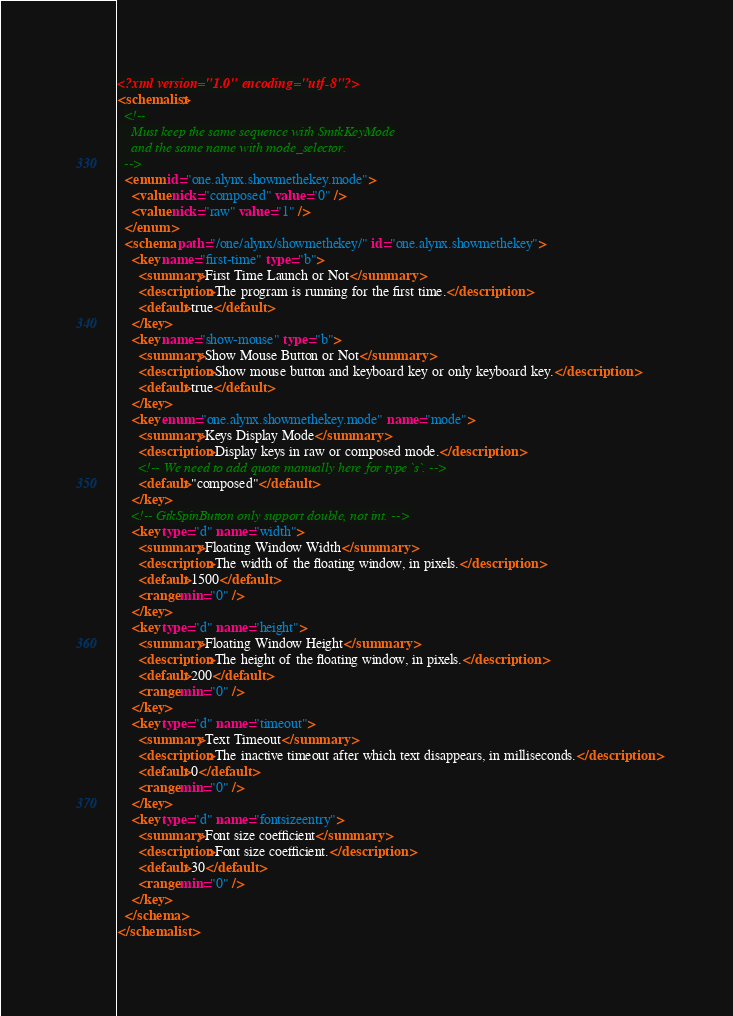<code> <loc_0><loc_0><loc_500><loc_500><_XML_><?xml version="1.0" encoding="utf-8"?>
<schemalist>
  <!--
    Must keep the same sequence with SmtkKeyMode
    and the same name with mode_selector.
  -->
  <enum id="one.alynx.showmethekey.mode">
    <value nick="composed" value="0" />
    <value nick="raw" value="1" />
  </enum>
  <schema path="/one/alynx/showmethekey/" id="one.alynx.showmethekey">
    <key name="first-time" type="b">
      <summary>First Time Launch or Not</summary>
      <description>The program is running for the first time.</description>
      <default>true</default>
    </key>
    <key name="show-mouse" type="b">
      <summary>Show Mouse Button or Not</summary>
      <description>Show mouse button and keyboard key or only keyboard key.</description>
      <default>true</default>
    </key>
    <key enum="one.alynx.showmethekey.mode" name="mode">
      <summary>Keys Display Mode</summary>
      <description>Display keys in raw or composed mode.</description>
      <!-- We need to add quote manually here for type `s`. -->
      <default>"composed"</default>
    </key>
    <!-- GtkSpinButton only support double, not int. -->
    <key type="d" name="width">
      <summary>Floating Window Width</summary>
      <description>The width of the floating window, in pixels.</description>
      <default>1500</default>
      <range min="0" />
    </key>
    <key type="d" name="height">
      <summary>Floating Window Height</summary>
      <description>The height of the floating window, in pixels.</description>
      <default>200</default>
      <range min="0" />
    </key>
    <key type="d" name="timeout">
      <summary>Text Timeout</summary>
      <description>The inactive timeout after which text disappears, in milliseconds.</description>
      <default>0</default>
      <range min="0" />
    </key>
    <key type="d" name="fontsizeentry">
      <summary>Font size coefficient</summary>
      <description>Font size coefficient.</description>
      <default>30</default>
      <range min="0" />
    </key>
  </schema>
</schemalist>
</code> 